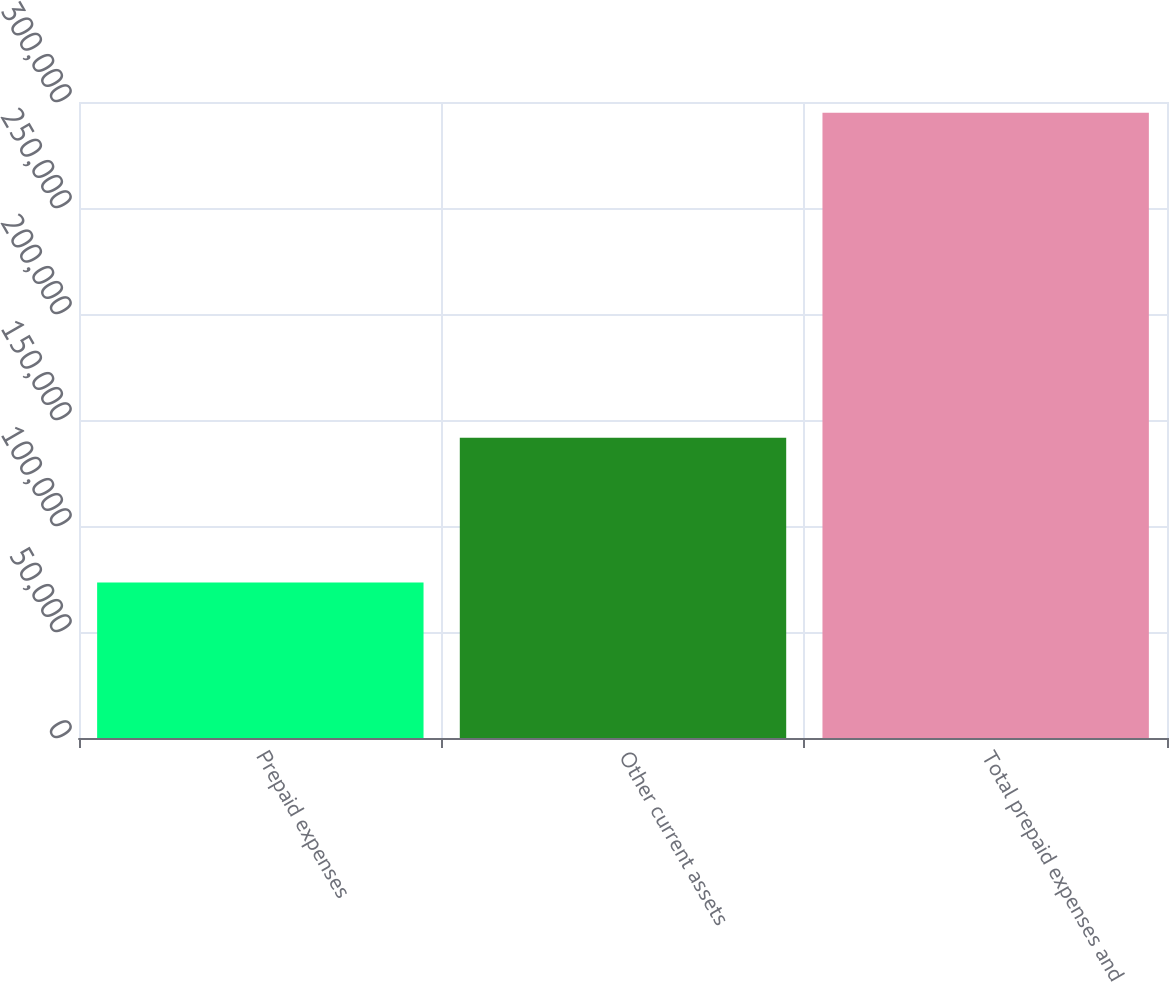Convert chart to OTSL. <chart><loc_0><loc_0><loc_500><loc_500><bar_chart><fcel>Prepaid expenses<fcel>Other current assets<fcel>Total prepaid expenses and<nl><fcel>73374<fcel>141581<fcel>294955<nl></chart> 